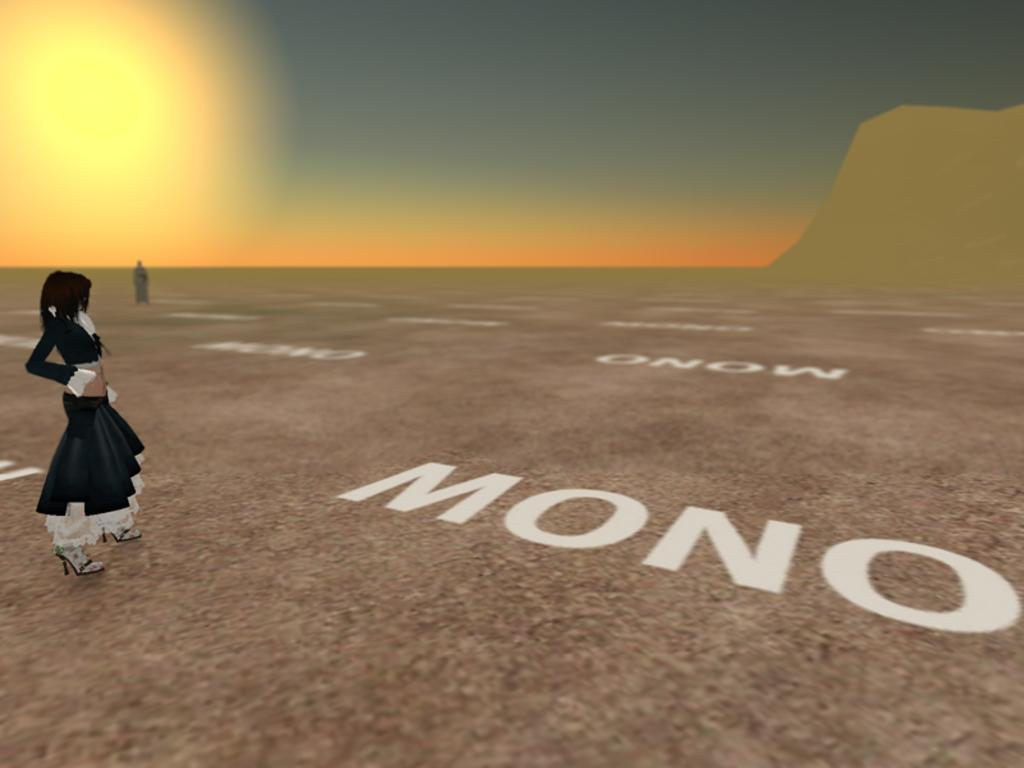What type of visual content is being described in the transcript? The transcript describes an animation. Reasoning: Since there are no specific facts about the image provided, we can only focus on the general description given in the transcript. We formulate a question that directly addresses the type of visual content being described, which is an animation. Absurd Question/Answer: What type of linen is used to create the animation? The transcript does not mention any linen being used in the animation, as it is a visual medium and not a physical object. How does the animation depict a person's knee? The transcript does not mention any specific details about the animation, such as characters or actions, so it is impossible to determine if a knee is depicted. 